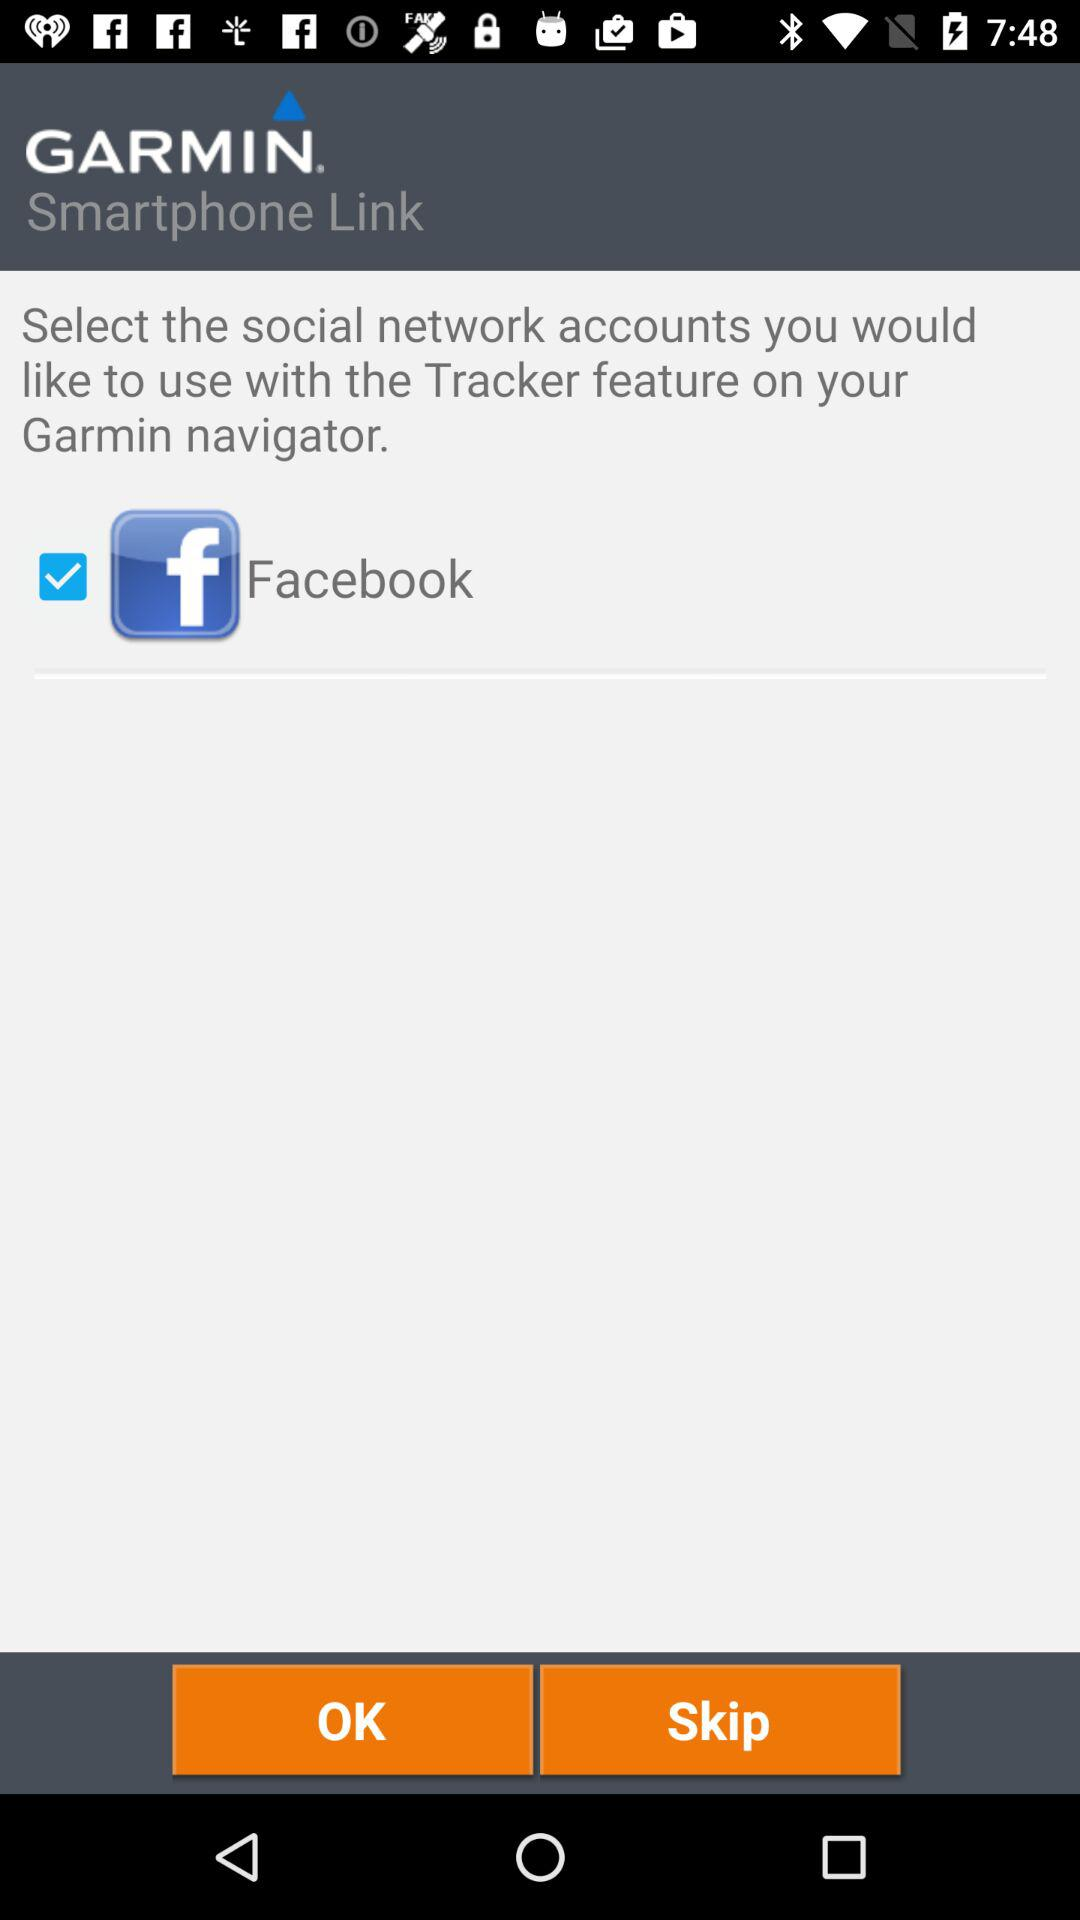Which social network account is selected?
Answer the question using a single word or phrase. Facebook 